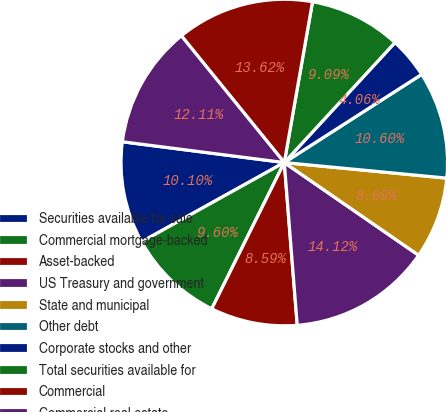Convert chart. <chart><loc_0><loc_0><loc_500><loc_500><pie_chart><fcel>Securities available for sale<fcel>Commercial mortgage-backed<fcel>Asset-backed<fcel>US Treasury and government<fcel>State and municipal<fcel>Other debt<fcel>Corporate stocks and other<fcel>Total securities available for<fcel>Commercial<fcel>Commercial real estate<nl><fcel>10.1%<fcel>9.6%<fcel>8.59%<fcel>14.12%<fcel>8.09%<fcel>10.6%<fcel>4.06%<fcel>9.09%<fcel>13.62%<fcel>12.11%<nl></chart> 